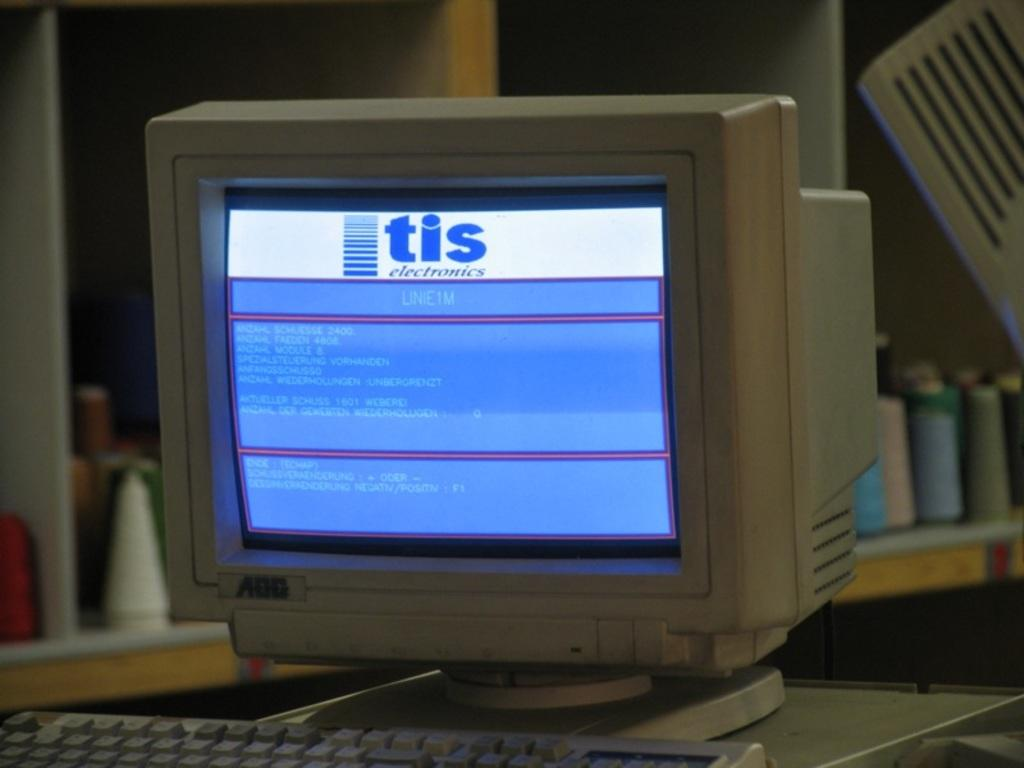Provide a one-sentence caption for the provided image. An old AOC crt monitor running software from TIS electronics. 